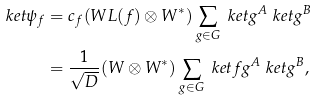Convert formula to latex. <formula><loc_0><loc_0><loc_500><loc_500>\ k e t { \psi _ { f } } & = c _ { f } ( W L ( f ) \otimes W ^ { \ast } ) \sum _ { g \in G } \ k e t { g } ^ { A } \ k e t { g } ^ { B } \\ & = \frac { 1 } { \sqrt { D } } ( W \otimes W ^ { \ast } ) \sum _ { g \in G } \ k e t { f g } ^ { A } \ k e t { g } ^ { B } ,</formula> 